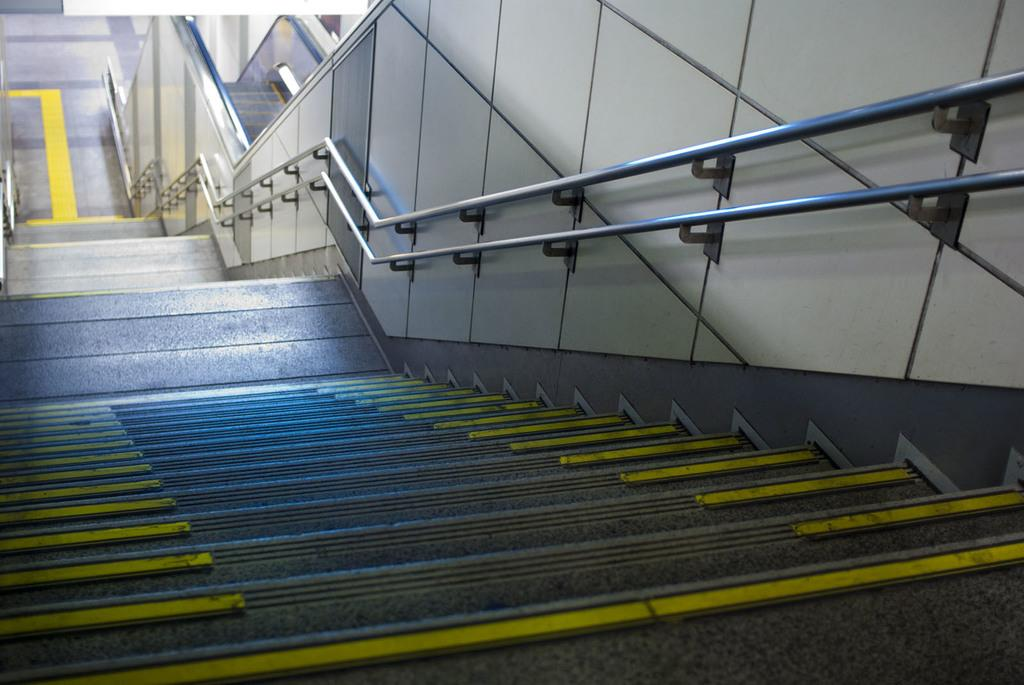What type of structure is present in the image? There are stairs in the image. What else can be seen in the image besides the stairs? There are rods in the image. What color are the lines on the stairs? The lines on the stairs are yellow. Are there any other yellow lines visible in the image? Yes, there are yellow lines on the ground. How does the process of digestion affect the growth of the rods in the image? There is no information about digestion or growth in the image, as it only features stairs, rods, and yellow lines. 